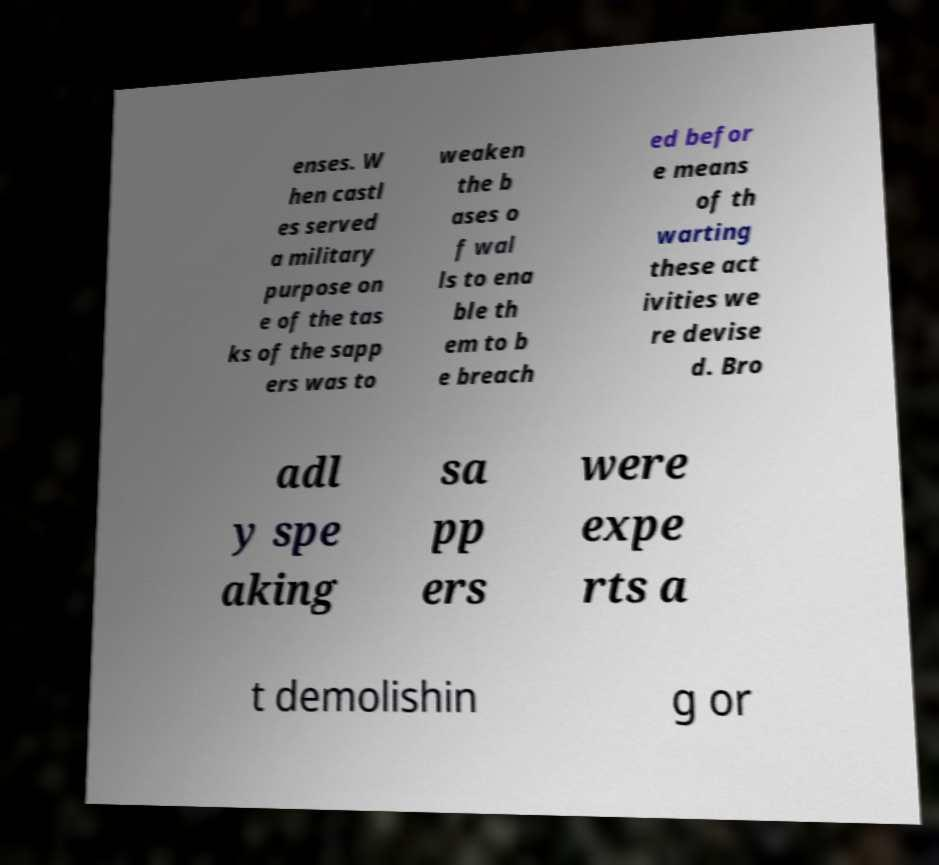For documentation purposes, I need the text within this image transcribed. Could you provide that? enses. W hen castl es served a military purpose on e of the tas ks of the sapp ers was to weaken the b ases o f wal ls to ena ble th em to b e breach ed befor e means of th warting these act ivities we re devise d. Bro adl y spe aking sa pp ers were expe rts a t demolishin g or 